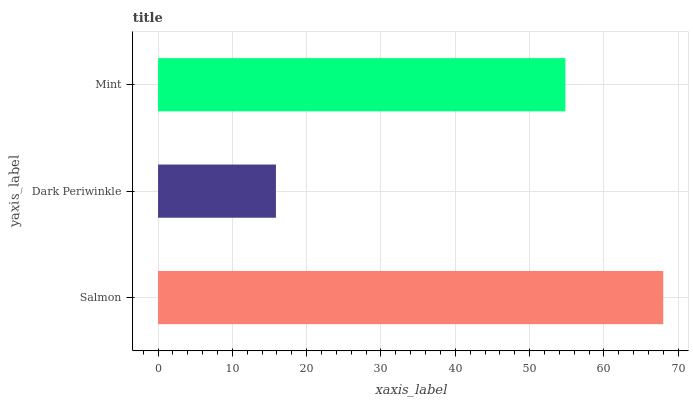Is Dark Periwinkle the minimum?
Answer yes or no. Yes. Is Salmon the maximum?
Answer yes or no. Yes. Is Mint the minimum?
Answer yes or no. No. Is Mint the maximum?
Answer yes or no. No. Is Mint greater than Dark Periwinkle?
Answer yes or no. Yes. Is Dark Periwinkle less than Mint?
Answer yes or no. Yes. Is Dark Periwinkle greater than Mint?
Answer yes or no. No. Is Mint less than Dark Periwinkle?
Answer yes or no. No. Is Mint the high median?
Answer yes or no. Yes. Is Mint the low median?
Answer yes or no. Yes. Is Dark Periwinkle the high median?
Answer yes or no. No. Is Dark Periwinkle the low median?
Answer yes or no. No. 